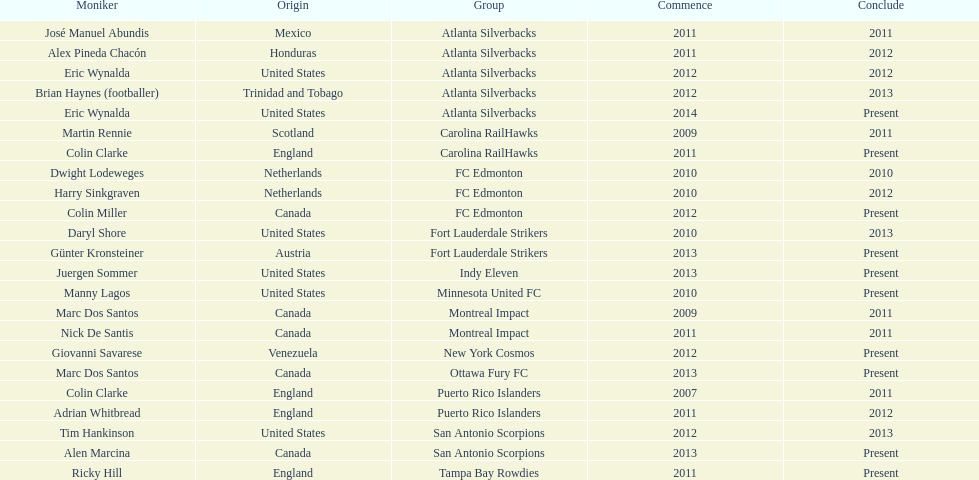How long did colin clarke coach the puerto rico islanders for? 4 years. 